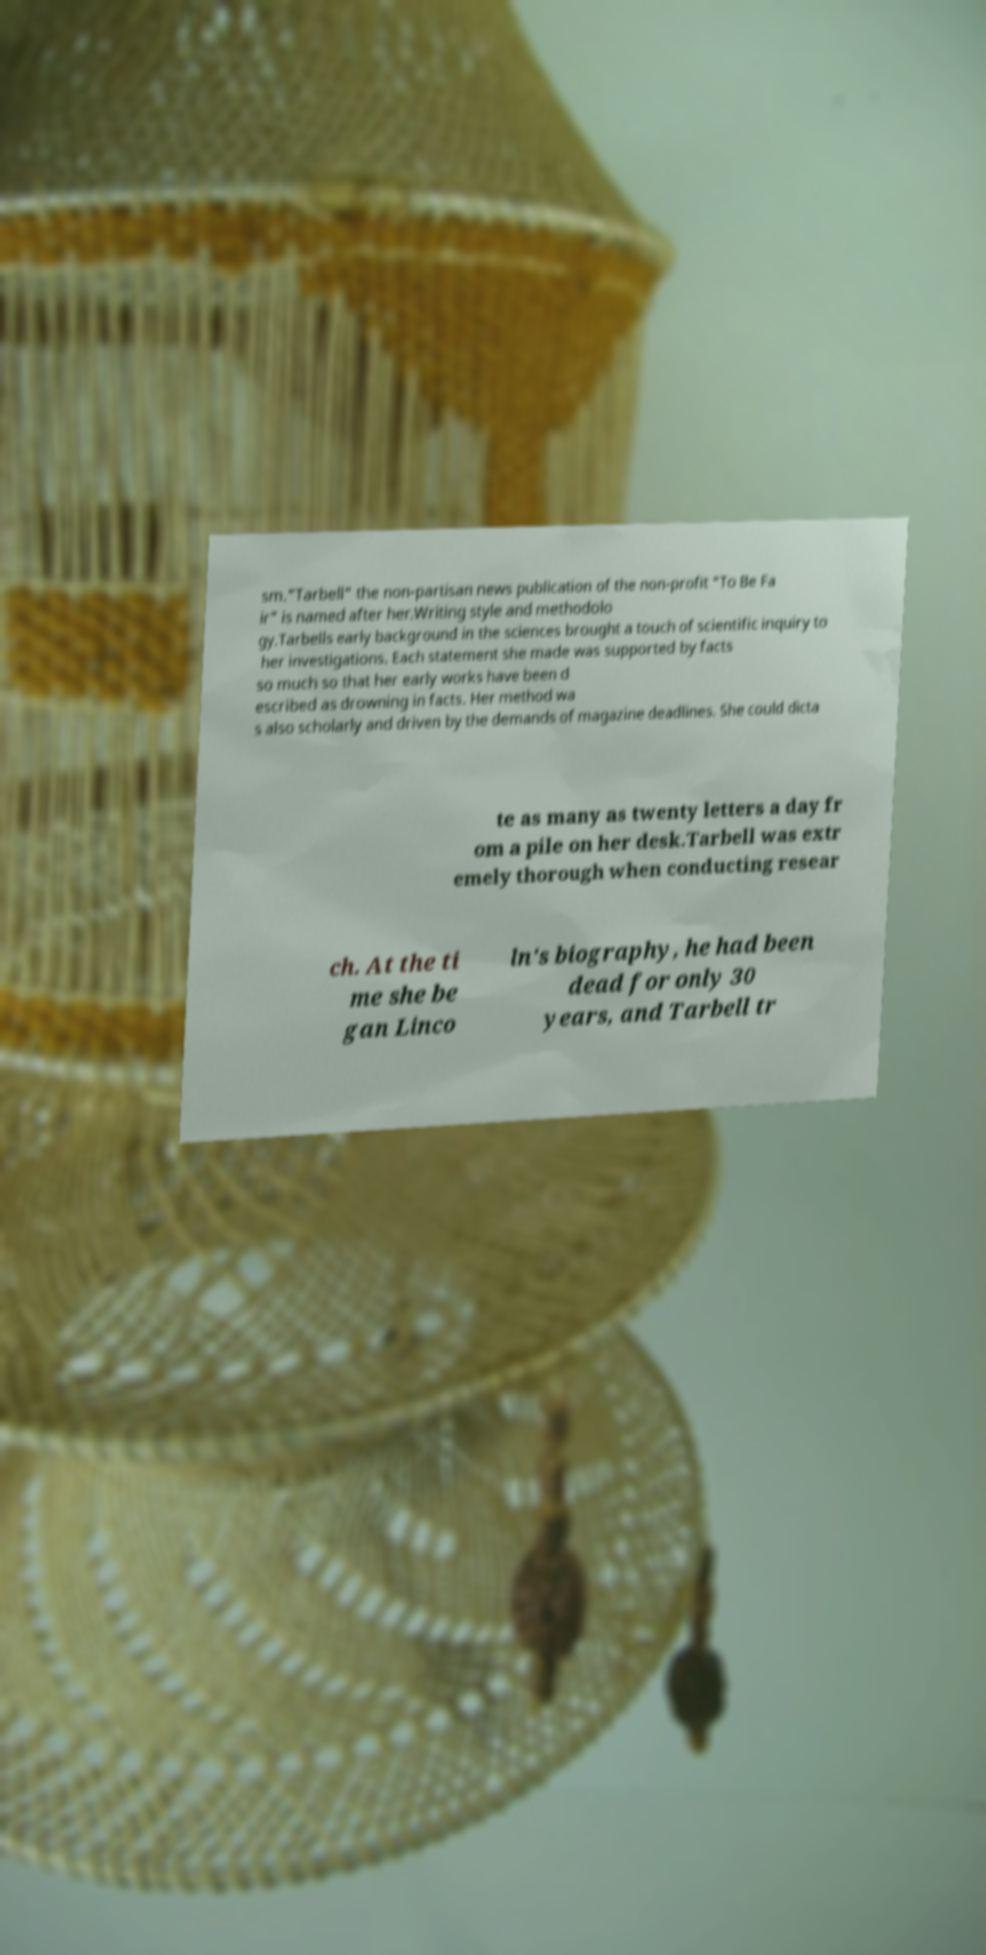There's text embedded in this image that I need extracted. Can you transcribe it verbatim? sm."Tarbell" the non-partisan news publication of the non-profit "To Be Fa ir" is named after her.Writing style and methodolo gy.Tarbells early background in the sciences brought a touch of scientific inquiry to her investigations. Each statement she made was supported by facts so much so that her early works have been d escribed as drowning in facts. Her method wa s also scholarly and driven by the demands of magazine deadlines. She could dicta te as many as twenty letters a day fr om a pile on her desk.Tarbell was extr emely thorough when conducting resear ch. At the ti me she be gan Linco ln's biography, he had been dead for only 30 years, and Tarbell tr 